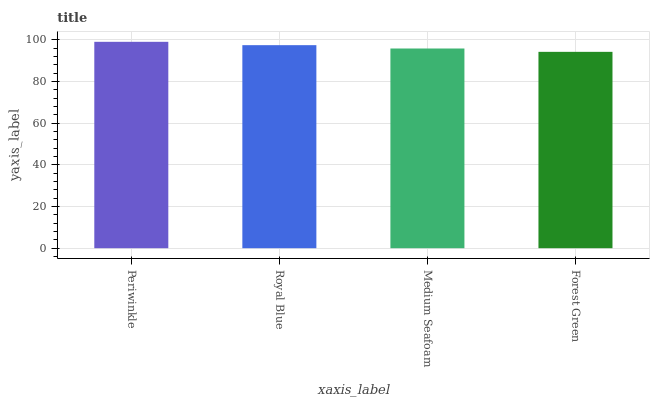Is Forest Green the minimum?
Answer yes or no. Yes. Is Periwinkle the maximum?
Answer yes or no. Yes. Is Royal Blue the minimum?
Answer yes or no. No. Is Royal Blue the maximum?
Answer yes or no. No. Is Periwinkle greater than Royal Blue?
Answer yes or no. Yes. Is Royal Blue less than Periwinkle?
Answer yes or no. Yes. Is Royal Blue greater than Periwinkle?
Answer yes or no. No. Is Periwinkle less than Royal Blue?
Answer yes or no. No. Is Royal Blue the high median?
Answer yes or no. Yes. Is Medium Seafoam the low median?
Answer yes or no. Yes. Is Medium Seafoam the high median?
Answer yes or no. No. Is Periwinkle the low median?
Answer yes or no. No. 